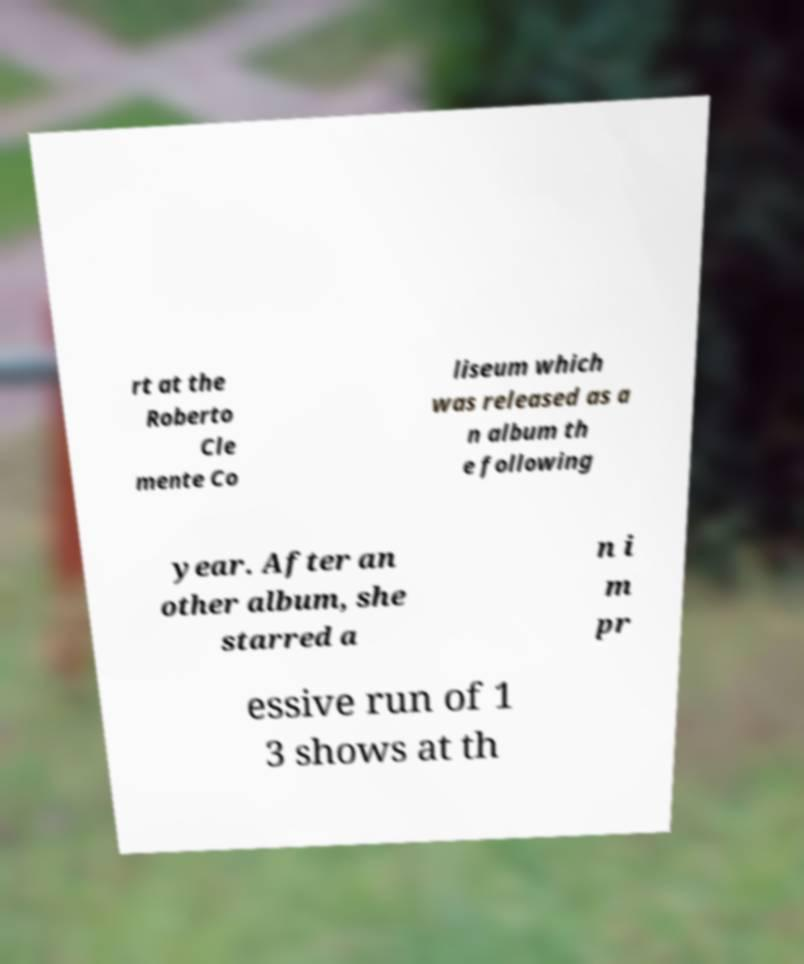There's text embedded in this image that I need extracted. Can you transcribe it verbatim? rt at the Roberto Cle mente Co liseum which was released as a n album th e following year. After an other album, she starred a n i m pr essive run of 1 3 shows at th 